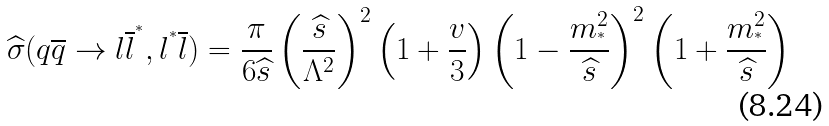<formula> <loc_0><loc_0><loc_500><loc_500>\widehat { \sigma } ( q \overline { q } \rightarrow l \overline { l } ^ { ^ { * } } , l ^ { ^ { * } } \overline { l } ) = \frac { \pi } { 6 \widehat { s } } \left ( \frac { \widehat { s } } { \Lambda ^ { 2 } } \right ) ^ { 2 } \left ( 1 + \frac { v } { 3 } \right ) \left ( 1 - \frac { m _ { ^ { * } } ^ { 2 } } { \widehat { s } } \right ) ^ { 2 } \left ( 1 + \frac { m _ { ^ { * } } ^ { 2 } } { \widehat { s } } \right )</formula> 